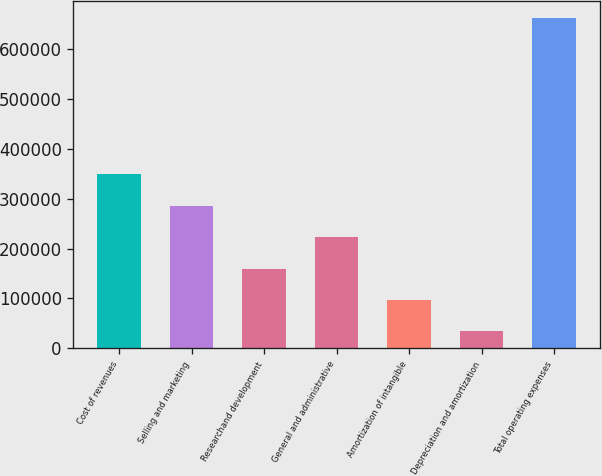<chart> <loc_0><loc_0><loc_500><loc_500><bar_chart><fcel>Cost of revenues<fcel>Selling and marketing<fcel>Researchand development<fcel>General and administrative<fcel>Amortization of intangible<fcel>Depreciation and amortization<fcel>Total operating expenses<nl><fcel>348442<fcel>285618<fcel>159969<fcel>222794<fcel>97144.5<fcel>34320<fcel>662565<nl></chart> 